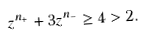<formula> <loc_0><loc_0><loc_500><loc_500>z ^ { n _ { + } } + 3 z ^ { n _ { - } } \geq 4 > 2 .</formula> 